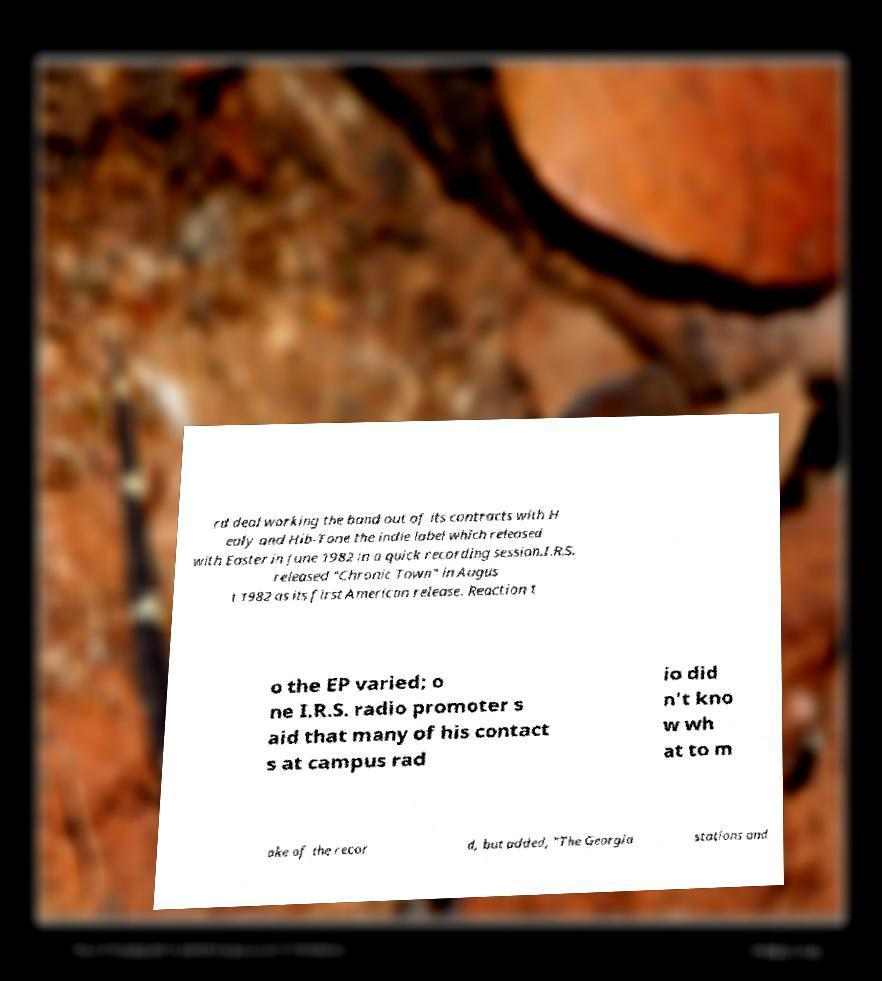For documentation purposes, I need the text within this image transcribed. Could you provide that? rd deal working the band out of its contracts with H ealy and Hib-Tone the indie label which released with Easter in June 1982 in a quick recording session.I.R.S. released "Chronic Town" in Augus t 1982 as its first American release. Reaction t o the EP varied; o ne I.R.S. radio promoter s aid that many of his contact s at campus rad io did n't kno w wh at to m ake of the recor d, but added, "The Georgia stations and 